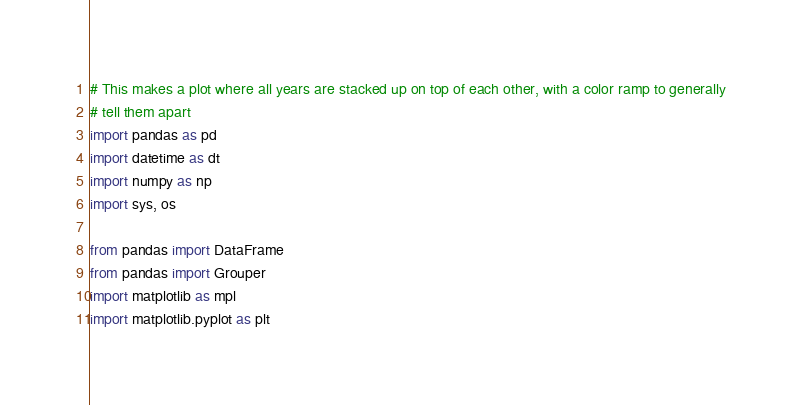<code> <loc_0><loc_0><loc_500><loc_500><_Python_># This makes a plot where all years are stacked up on top of each other, with a color ramp to generally
# tell them apart
import pandas as pd
import datetime as dt
import numpy as np
import sys, os

from pandas import DataFrame
from pandas import Grouper
import matplotlib as mpl
import matplotlib.pyplot as plt</code> 